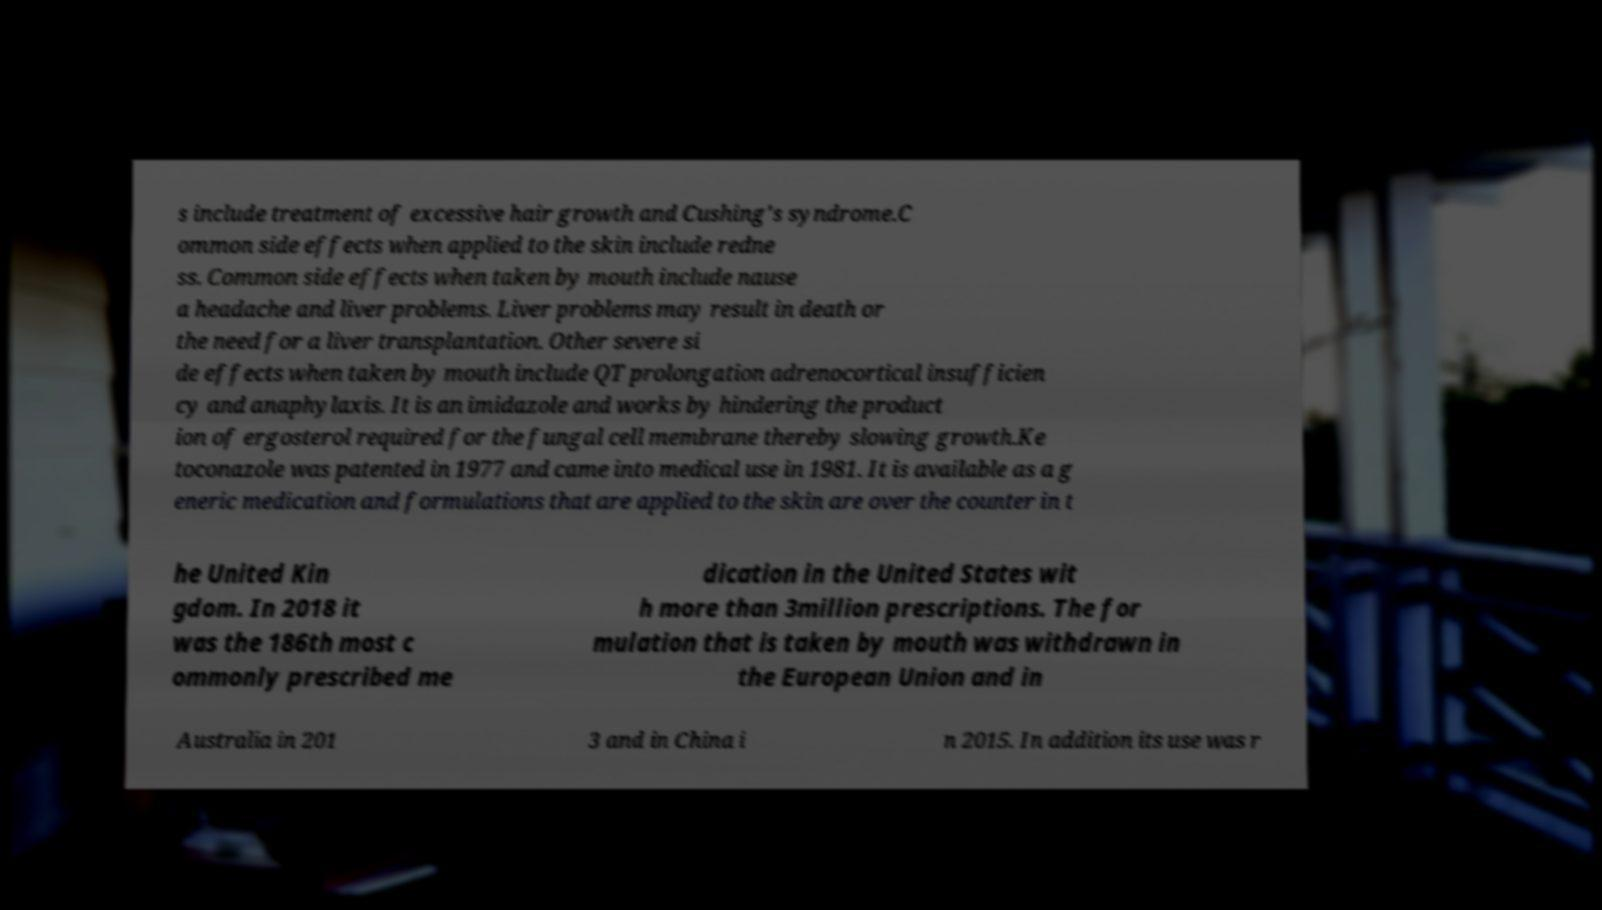I need the written content from this picture converted into text. Can you do that? s include treatment of excessive hair growth and Cushing's syndrome.C ommon side effects when applied to the skin include redne ss. Common side effects when taken by mouth include nause a headache and liver problems. Liver problems may result in death or the need for a liver transplantation. Other severe si de effects when taken by mouth include QT prolongation adrenocortical insufficien cy and anaphylaxis. It is an imidazole and works by hindering the product ion of ergosterol required for the fungal cell membrane thereby slowing growth.Ke toconazole was patented in 1977 and came into medical use in 1981. It is available as a g eneric medication and formulations that are applied to the skin are over the counter in t he United Kin gdom. In 2018 it was the 186th most c ommonly prescribed me dication in the United States wit h more than 3million prescriptions. The for mulation that is taken by mouth was withdrawn in the European Union and in Australia in 201 3 and in China i n 2015. In addition its use was r 